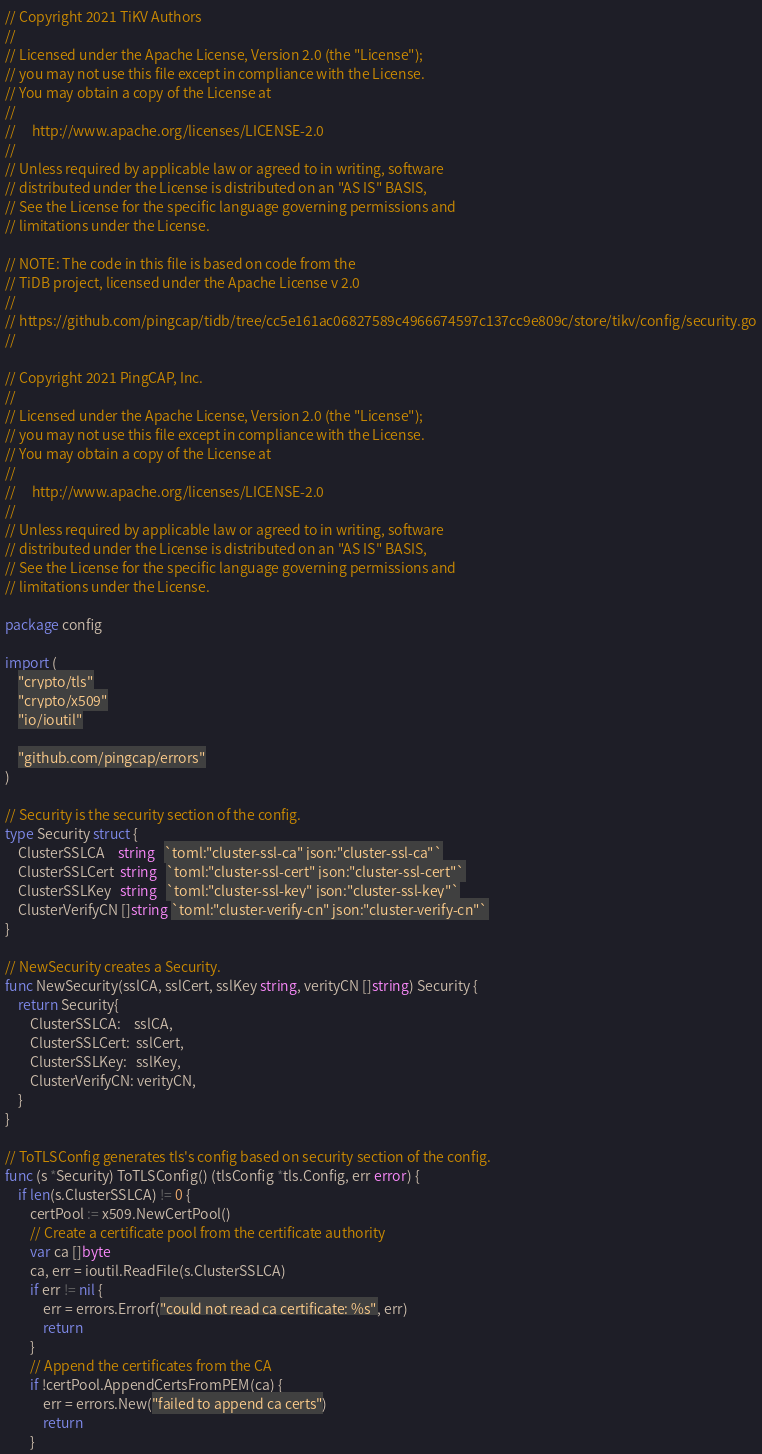<code> <loc_0><loc_0><loc_500><loc_500><_Go_>// Copyright 2021 TiKV Authors
//
// Licensed under the Apache License, Version 2.0 (the "License");
// you may not use this file except in compliance with the License.
// You may obtain a copy of the License at
//
//     http://www.apache.org/licenses/LICENSE-2.0
//
// Unless required by applicable law or agreed to in writing, software
// distributed under the License is distributed on an "AS IS" BASIS,
// See the License for the specific language governing permissions and
// limitations under the License.

// NOTE: The code in this file is based on code from the
// TiDB project, licensed under the Apache License v 2.0
//
// https://github.com/pingcap/tidb/tree/cc5e161ac06827589c4966674597c137cc9e809c/store/tikv/config/security.go
//

// Copyright 2021 PingCAP, Inc.
//
// Licensed under the Apache License, Version 2.0 (the "License");
// you may not use this file except in compliance with the License.
// You may obtain a copy of the License at
//
//     http://www.apache.org/licenses/LICENSE-2.0
//
// Unless required by applicable law or agreed to in writing, software
// distributed under the License is distributed on an "AS IS" BASIS,
// See the License for the specific language governing permissions and
// limitations under the License.

package config

import (
	"crypto/tls"
	"crypto/x509"
	"io/ioutil"

	"github.com/pingcap/errors"
)

// Security is the security section of the config.
type Security struct {
	ClusterSSLCA    string   `toml:"cluster-ssl-ca" json:"cluster-ssl-ca"`
	ClusterSSLCert  string   `toml:"cluster-ssl-cert" json:"cluster-ssl-cert"`
	ClusterSSLKey   string   `toml:"cluster-ssl-key" json:"cluster-ssl-key"`
	ClusterVerifyCN []string `toml:"cluster-verify-cn" json:"cluster-verify-cn"`
}

// NewSecurity creates a Security.
func NewSecurity(sslCA, sslCert, sslKey string, verityCN []string) Security {
	return Security{
		ClusterSSLCA:    sslCA,
		ClusterSSLCert:  sslCert,
		ClusterSSLKey:   sslKey,
		ClusterVerifyCN: verityCN,
	}
}

// ToTLSConfig generates tls's config based on security section of the config.
func (s *Security) ToTLSConfig() (tlsConfig *tls.Config, err error) {
	if len(s.ClusterSSLCA) != 0 {
		certPool := x509.NewCertPool()
		// Create a certificate pool from the certificate authority
		var ca []byte
		ca, err = ioutil.ReadFile(s.ClusterSSLCA)
		if err != nil {
			err = errors.Errorf("could not read ca certificate: %s", err)
			return
		}
		// Append the certificates from the CA
		if !certPool.AppendCertsFromPEM(ca) {
			err = errors.New("failed to append ca certs")
			return
		}</code> 